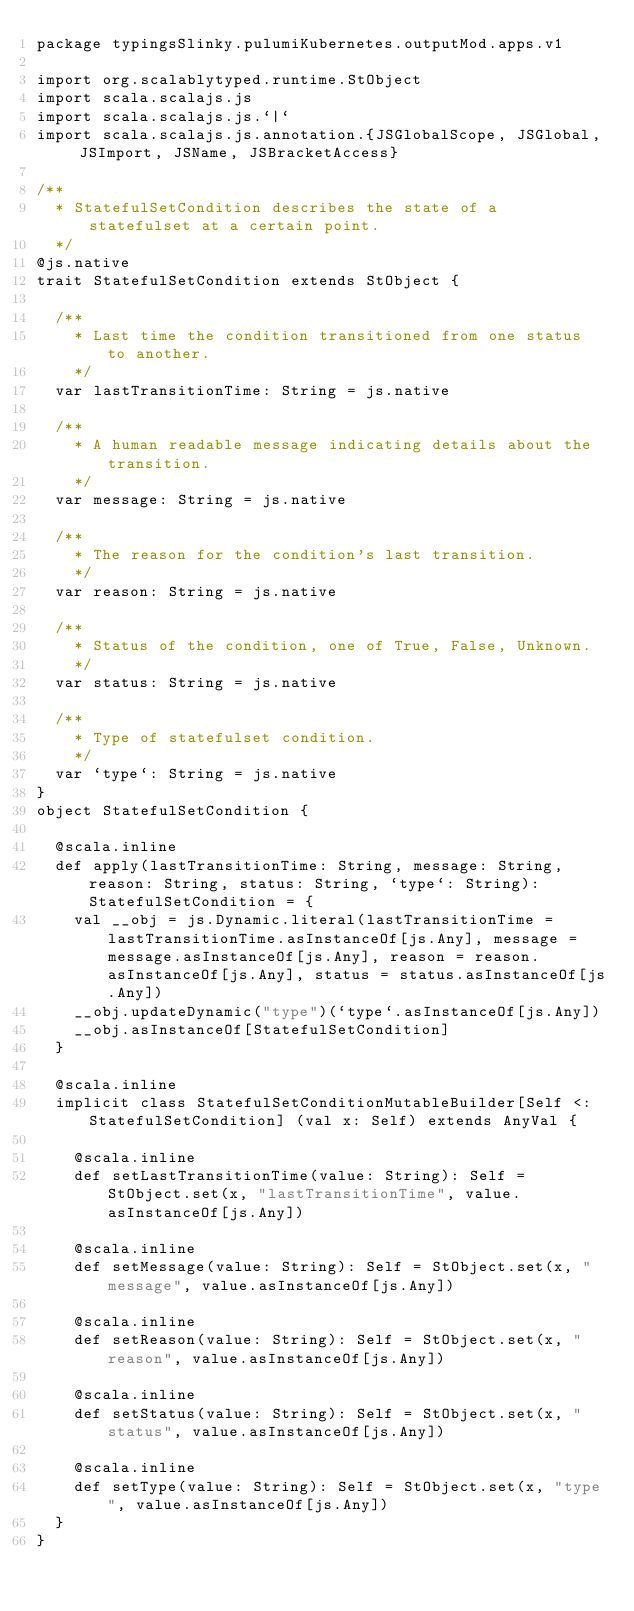<code> <loc_0><loc_0><loc_500><loc_500><_Scala_>package typingsSlinky.pulumiKubernetes.outputMod.apps.v1

import org.scalablytyped.runtime.StObject
import scala.scalajs.js
import scala.scalajs.js.`|`
import scala.scalajs.js.annotation.{JSGlobalScope, JSGlobal, JSImport, JSName, JSBracketAccess}

/**
  * StatefulSetCondition describes the state of a statefulset at a certain point.
  */
@js.native
trait StatefulSetCondition extends StObject {
  
  /**
    * Last time the condition transitioned from one status to another.
    */
  var lastTransitionTime: String = js.native
  
  /**
    * A human readable message indicating details about the transition.
    */
  var message: String = js.native
  
  /**
    * The reason for the condition's last transition.
    */
  var reason: String = js.native
  
  /**
    * Status of the condition, one of True, False, Unknown.
    */
  var status: String = js.native
  
  /**
    * Type of statefulset condition.
    */
  var `type`: String = js.native
}
object StatefulSetCondition {
  
  @scala.inline
  def apply(lastTransitionTime: String, message: String, reason: String, status: String, `type`: String): StatefulSetCondition = {
    val __obj = js.Dynamic.literal(lastTransitionTime = lastTransitionTime.asInstanceOf[js.Any], message = message.asInstanceOf[js.Any], reason = reason.asInstanceOf[js.Any], status = status.asInstanceOf[js.Any])
    __obj.updateDynamic("type")(`type`.asInstanceOf[js.Any])
    __obj.asInstanceOf[StatefulSetCondition]
  }
  
  @scala.inline
  implicit class StatefulSetConditionMutableBuilder[Self <: StatefulSetCondition] (val x: Self) extends AnyVal {
    
    @scala.inline
    def setLastTransitionTime(value: String): Self = StObject.set(x, "lastTransitionTime", value.asInstanceOf[js.Any])
    
    @scala.inline
    def setMessage(value: String): Self = StObject.set(x, "message", value.asInstanceOf[js.Any])
    
    @scala.inline
    def setReason(value: String): Self = StObject.set(x, "reason", value.asInstanceOf[js.Any])
    
    @scala.inline
    def setStatus(value: String): Self = StObject.set(x, "status", value.asInstanceOf[js.Any])
    
    @scala.inline
    def setType(value: String): Self = StObject.set(x, "type", value.asInstanceOf[js.Any])
  }
}
</code> 